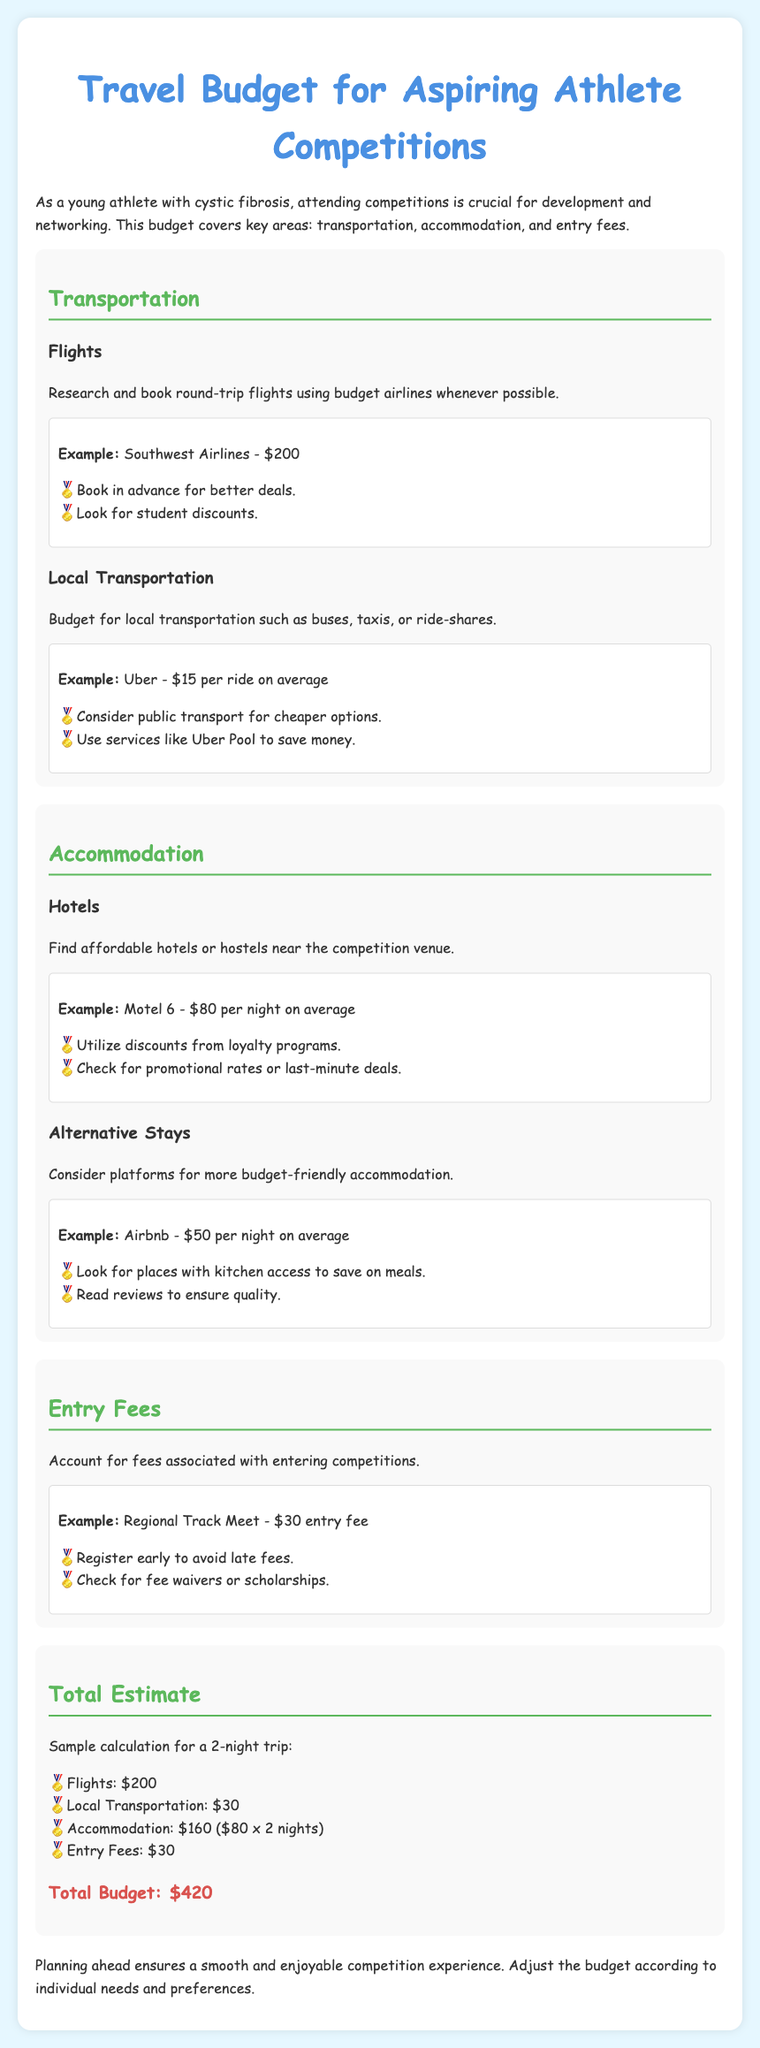What is the average cost of a round-trip flight? The document states the example of a round-trip flight using Southwest Airlines costs $200.
Answer: $200 What is the average local transportation cost per ride? The document mentions that the average cost for an Uber ride is $15.
Answer: $15 How much does it cost to stay at Motel 6 per night? The example provided indicates that Motel 6 costs $80 per night on average.
Answer: $80 What is the entry fee for the Regional Track Meet? The document specifies that the entry fee for the Regional Track Meet is $30.
Answer: $30 What is the total budget for a 2-night trip? The document includes a sample calculation which totals the budget at $420.
Answer: $420 How many nights is the sample trip planned for? The document describes a budget calculation for a 2-night trip.
Answer: 2 nights What discount options are suggested for local transportation? The document recommends considering public transport for cheaper options.
Answer: Public transport What alternative accommodation is suggested to save money? The document mentions using Airbnb as a budget-friendly option for accommodation.
Answer: Airbnb What should be done to avoid late entry fees? The document advises registering early to avoid late fees.
Answer: Register early 